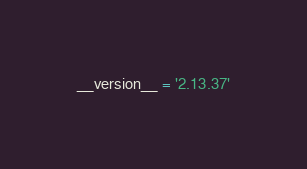<code> <loc_0><loc_0><loc_500><loc_500><_Python_>__version__ = '2.13.37'</code> 